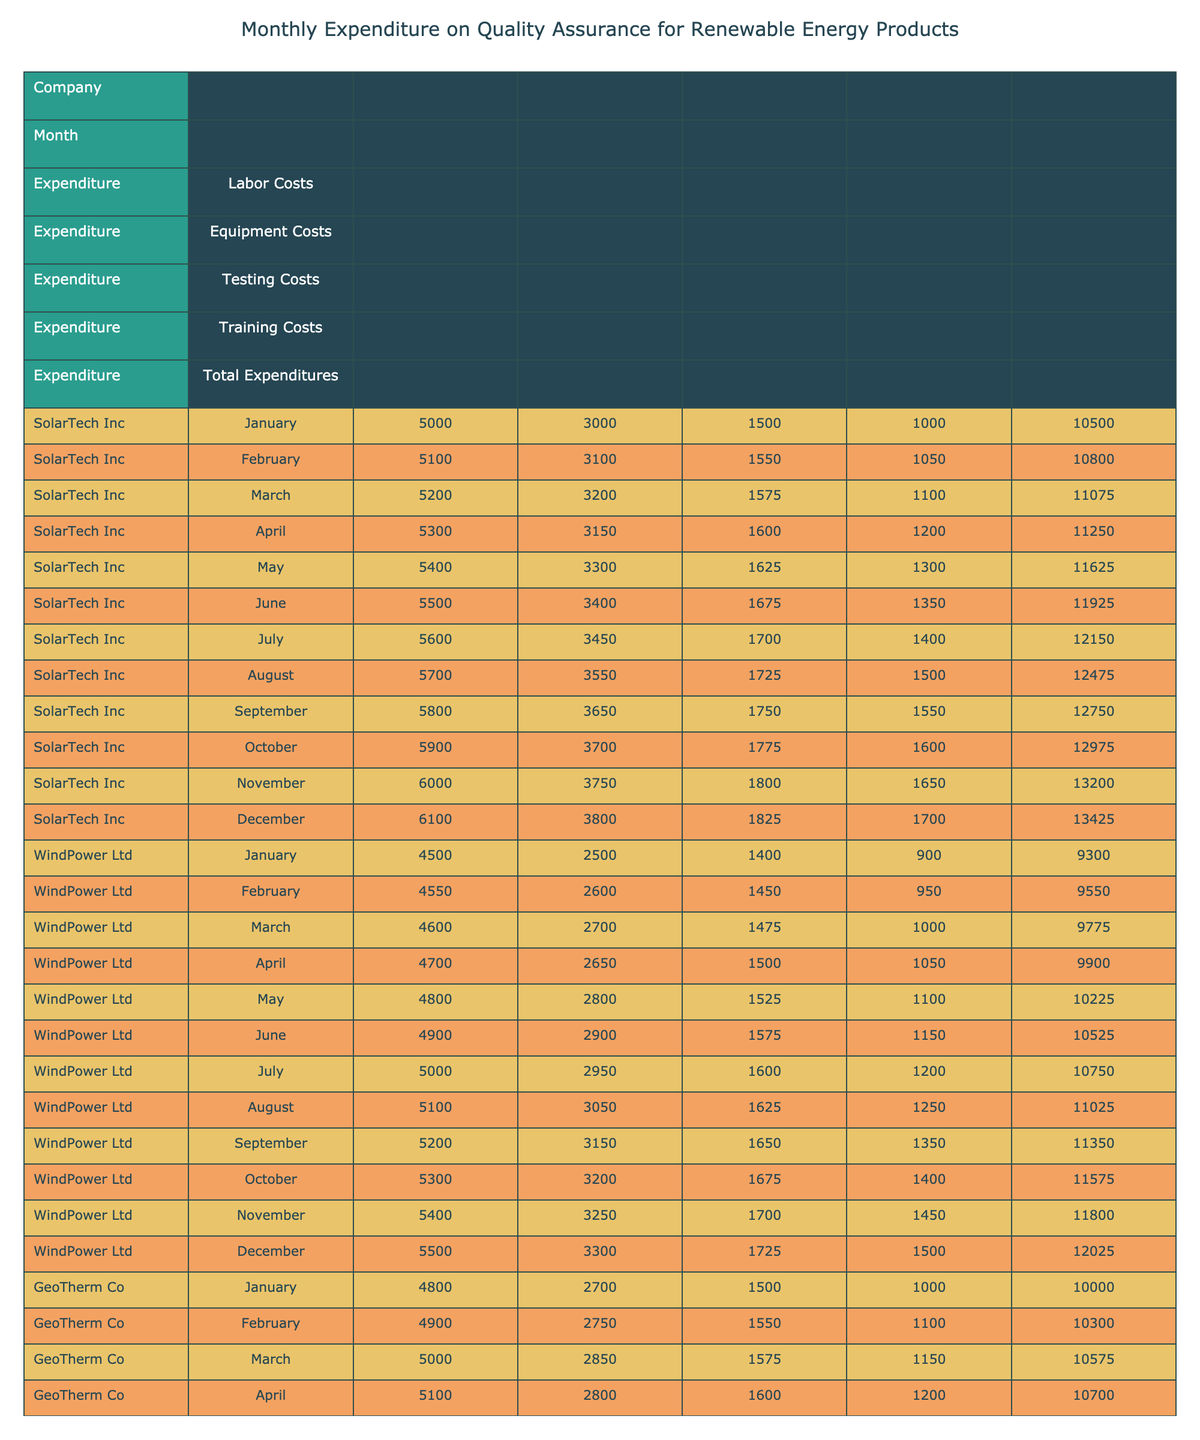What were the total expenditures for SolarTech Inc in December? Looking at the row for SolarTech Inc in December, the total expenditures column shows 13425.
Answer: 13425 Which company had the highest equipment costs in March? In March, SolarTech Inc had equipment costs of 3200, WindPower Ltd had 2700, and GeoTherm Co had 2850. SolarTech Inc has the highest at 3200.
Answer: SolarTech Inc What is the difference between the total expenditures of WindPower Ltd in January and December? WindPower Ltd had total expenditures of 9300 in January and 12025 in December. The difference is 12025 - 9300 = 2950.
Answer: 2950 What was the average labor cost for GeoTherm Co over the year? GeoTherm Co's labor costs are 4800, 4900, 5000, 5100, 5200, 5300, 5400, 5500, 5600, 5700, 5800, 5900. The sum is 63000 and divided by 12 gives an average of 5250.
Answer: 5250 Did WindPower Ltd have any month where the total expenditures were higher than 11500? Checking the total expenditures for WindPower Ltd, from January (9300) to December (12025), they exceed 11500 in September (11350) and beyond. Therefore, yes, they did.
Answer: Yes Which month saw the lowest total expenditures for GeoTherm Co? By examining each month for GeoTherm Co, January has the lowest total expenditures of 10000 compared to the others in the year.
Answer: January What were the total labor costs for SolarTech Inc from January to March? The labor costs for SolarTech Inc are 5000 (January) + 5100 (February) + 5200 (March). Adding these gives a total of 15300.
Answer: 15300 What percentage increase in total expenditures did SolarTech Inc experience from January to October? Total expenditures in January were 10500 and in October, it was 12975. The increase is 12975 - 10500 = 2475. The percentage increase is (2475 / 10500) * 100 ≈ 23.5%.
Answer: 23.5% Which company had the most consistent training costs throughout the year? Reviewing the training costs for each company, WindPower Ltd showed the least variation, ranging from 900 to 1500 compared to others that varied more widely.
Answer: WindPower Ltd 